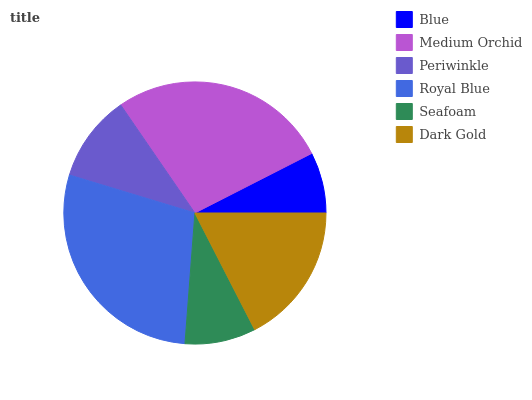Is Blue the minimum?
Answer yes or no. Yes. Is Royal Blue the maximum?
Answer yes or no. Yes. Is Medium Orchid the minimum?
Answer yes or no. No. Is Medium Orchid the maximum?
Answer yes or no. No. Is Medium Orchid greater than Blue?
Answer yes or no. Yes. Is Blue less than Medium Orchid?
Answer yes or no. Yes. Is Blue greater than Medium Orchid?
Answer yes or no. No. Is Medium Orchid less than Blue?
Answer yes or no. No. Is Dark Gold the high median?
Answer yes or no. Yes. Is Periwinkle the low median?
Answer yes or no. Yes. Is Periwinkle the high median?
Answer yes or no. No. Is Seafoam the low median?
Answer yes or no. No. 